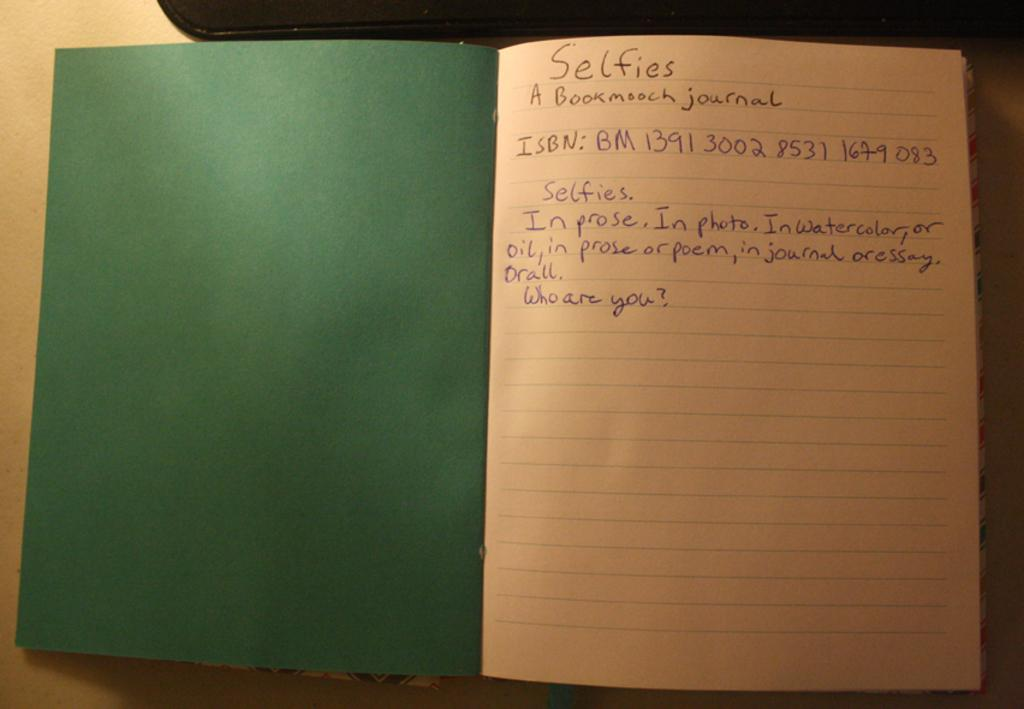Provide a one-sentence caption for the provided image. A notebook that has a green cover and on the first page is information on selfies. 